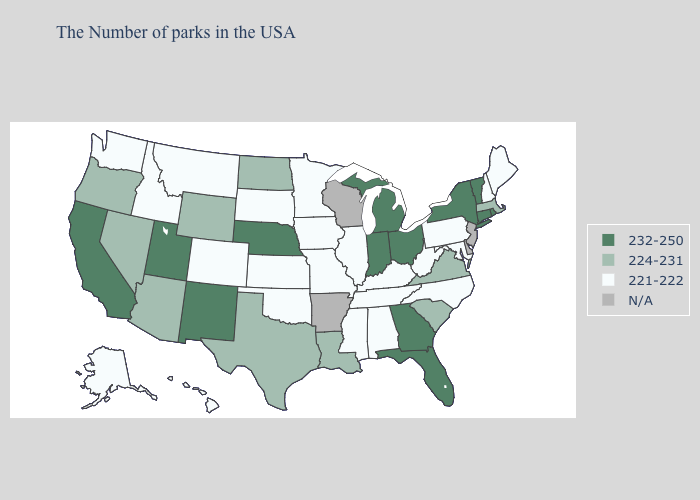How many symbols are there in the legend?
Short answer required. 4. Name the states that have a value in the range N/A?
Keep it brief. New Jersey, Delaware, Wisconsin, Arkansas. Does the map have missing data?
Quick response, please. Yes. Name the states that have a value in the range 221-222?
Give a very brief answer. Maine, New Hampshire, Maryland, Pennsylvania, North Carolina, West Virginia, Kentucky, Alabama, Tennessee, Illinois, Mississippi, Missouri, Minnesota, Iowa, Kansas, Oklahoma, South Dakota, Colorado, Montana, Idaho, Washington, Alaska, Hawaii. Name the states that have a value in the range 221-222?
Quick response, please. Maine, New Hampshire, Maryland, Pennsylvania, North Carolina, West Virginia, Kentucky, Alabama, Tennessee, Illinois, Mississippi, Missouri, Minnesota, Iowa, Kansas, Oklahoma, South Dakota, Colorado, Montana, Idaho, Washington, Alaska, Hawaii. Among the states that border New Hampshire , which have the highest value?
Write a very short answer. Vermont. Which states have the highest value in the USA?
Be succinct. Rhode Island, Vermont, Connecticut, New York, Ohio, Florida, Georgia, Michigan, Indiana, Nebraska, New Mexico, Utah, California. What is the value of Iowa?
Be succinct. 221-222. Does the first symbol in the legend represent the smallest category?
Write a very short answer. No. Among the states that border Pennsylvania , which have the highest value?
Concise answer only. New York, Ohio. How many symbols are there in the legend?
Keep it brief. 4. What is the highest value in the USA?
Give a very brief answer. 232-250. What is the value of Connecticut?
Keep it brief. 232-250. Name the states that have a value in the range 221-222?
Write a very short answer. Maine, New Hampshire, Maryland, Pennsylvania, North Carolina, West Virginia, Kentucky, Alabama, Tennessee, Illinois, Mississippi, Missouri, Minnesota, Iowa, Kansas, Oklahoma, South Dakota, Colorado, Montana, Idaho, Washington, Alaska, Hawaii. 